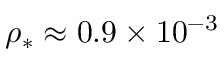Convert formula to latex. <formula><loc_0><loc_0><loc_500><loc_500>\rho _ { * } \approx 0 . 9 \times 1 0 ^ { - 3 }</formula> 